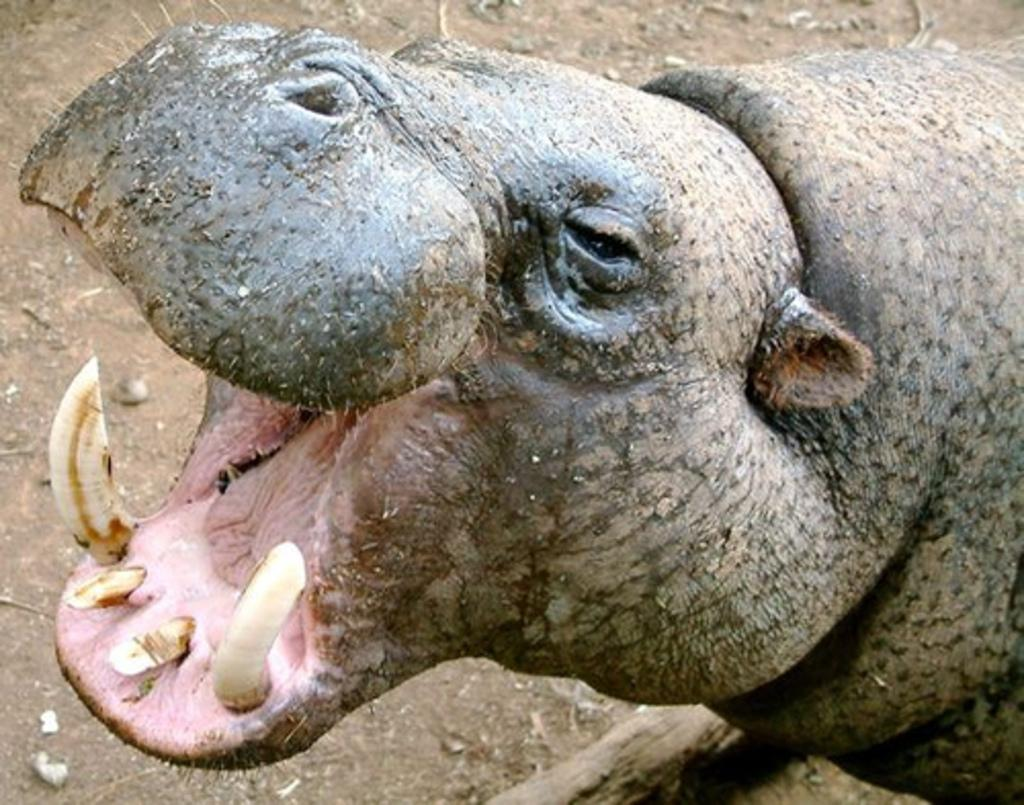What type of animal is in the image? The image contains a hippopotamus. Can you describe the color of the hippopotamus? The hippopotamus is black and light brown in color. What type of system is the fireman using to extinguish the moon in the image? There is no fireman or moon present in the image, and therefore no such activity can be observed. 